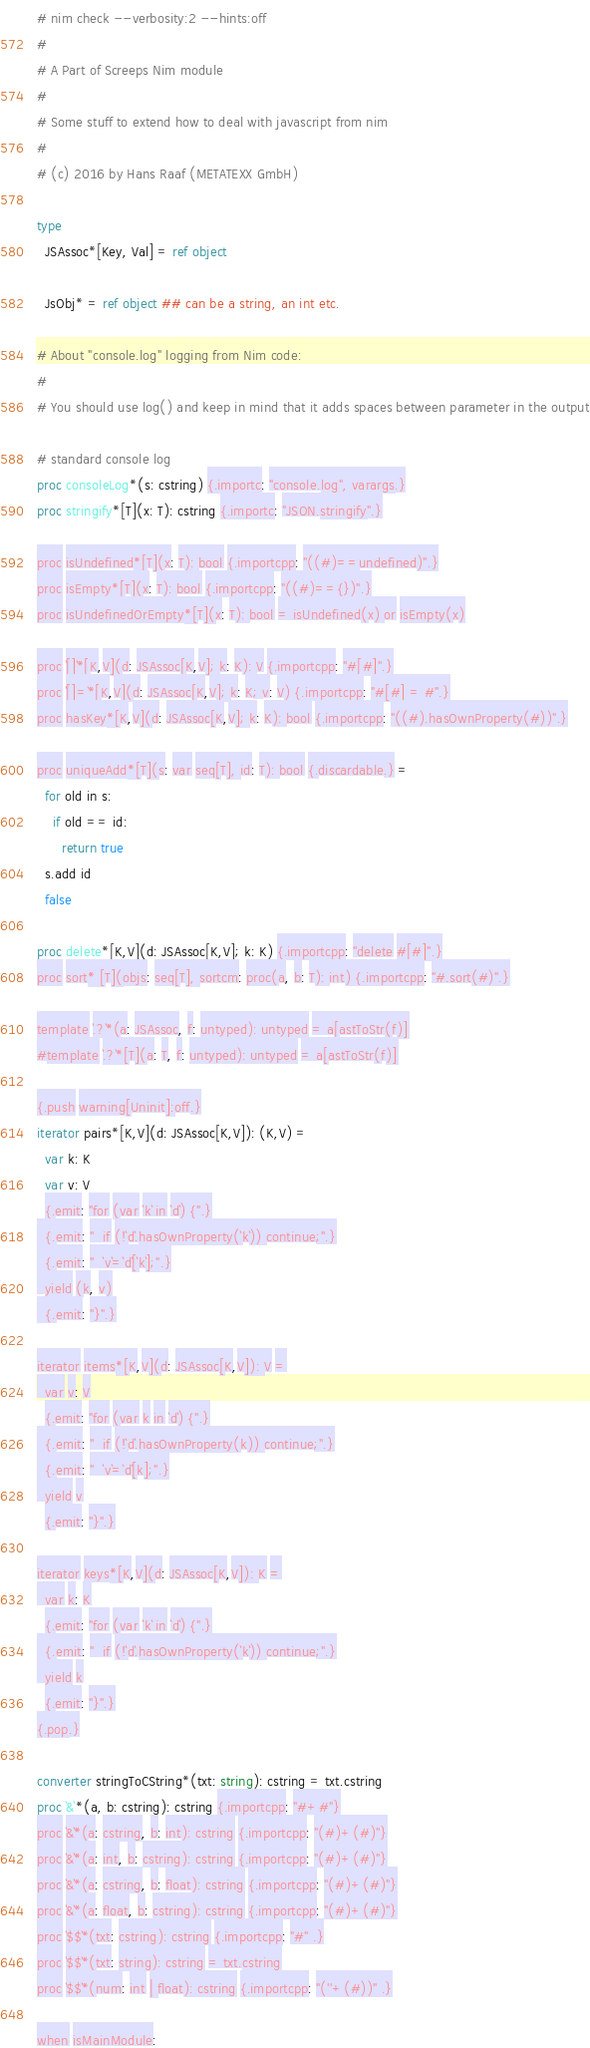<code> <loc_0><loc_0><loc_500><loc_500><_Nim_># nim check --verbosity:2 --hints:off
#
# A Part of Screeps Nim module
#
# Some stuff to extend how to deal with javascript from nim
#
# (c) 2016 by Hans Raaf (METATEXX GmbH)

type
  JSAssoc*[Key, Val] = ref object

  JsObj* = ref object ## can be a string, an int etc.

# About "console.log" logging from Nim code:
#
# You should use log() and keep in mind that it adds spaces between parameter in the output

# standard console log
proc consoleLog*(s: cstring) {.importc: "console.log", varargs.}
proc stringify*[T](x: T): cstring {.importc: "JSON.stringify".}

proc isUndefined*[T](x: T): bool {.importcpp: "((#)==undefined)".}
proc isEmpty*[T](x: T): bool {.importcpp: "((#)=={})".}
proc isUndefinedOrEmpty*[T](x: T): bool = isUndefined(x) or isEmpty(x)

proc `[]`*[K,V](d: JSAssoc[K,V]; k: K): V {.importcpp: "#[#]".}
proc `[]=`*[K,V](d: JSAssoc[K,V]; k: K; v: V) {.importcpp: "#[#] = #".}
proc hasKey*[K,V](d: JSAssoc[K,V]; k: K): bool {.importcpp: "((#).hasOwnProperty(#))".}

proc uniqueAdd*[T](s: var seq[T], id: T): bool {.discardable.} =
  for old in s:
    if old == id:
      return true
  s.add id
  false

proc delete*[K,V](d: JSAssoc[K,V]; k: K) {.importcpp: "delete #[#]".}
proc sort* [T](objs: seq[T], sortcm: proc(a, b: T): int) {.importcpp: "#.sort(#)".}

template `.?`*(a: JSAssoc, f: untyped): untyped = a[astToStr(f)]
#template `.?`*[T](a: T, f: untyped): untyped = a[astToStr(f)]

{.push warning[Uninit]:off.}
iterator pairs*[K,V](d: JSAssoc[K,V]): (K,V) =
  var k: K
  var v: V
  {.emit: "for (var `k` in `d`) {".}
  {.emit: "  if (!`d`.hasOwnProperty(`k`)) continue;".}
  {.emit: "  `v`=`d`[`k`];".}
  yield (k, v)
  {.emit: "}".}

iterator items*[K,V](d: JSAssoc[K,V]): V =
  var v: V
  {.emit: "for (var k in `d`) {".}
  {.emit: "  if (!`d`.hasOwnProperty(k)) continue;".}
  {.emit: "  `v`=`d`[k];".}
  yield v
  {.emit: "}".}

iterator keys*[K,V](d: JSAssoc[K,V]): K =
  var k: K
  {.emit: "for (var `k` in `d`) {".}
  {.emit: "  if (!`d`.hasOwnProperty(`k`)) continue;".}
  yield k
  {.emit: "}".}
{.pop.}

converter stringToCString*(txt: string): cstring = txt.cstring
proc `&`*(a, b: cstring): cstring {.importcpp: "#+#"}
proc `&`*(a: cstring, b: int): cstring {.importcpp: "(#)+(#)"}
proc `&`*(a: int, b: cstring): cstring {.importcpp: "(#)+(#)"}
proc `&`*(a: cstring, b: float): cstring {.importcpp: "(#)+(#)"}
proc `&`*(a: float, b: cstring): cstring {.importcpp: "(#)+(#)"}
proc `$$`*(txt: cstring): cstring {.importcpp: "#" .}
proc `$$`*(txt: string): cstring = txt.cstring
proc `$$`*(num: int | float): cstring {.importcpp: "(''+(#))" .}

when isMainModule:</code> 